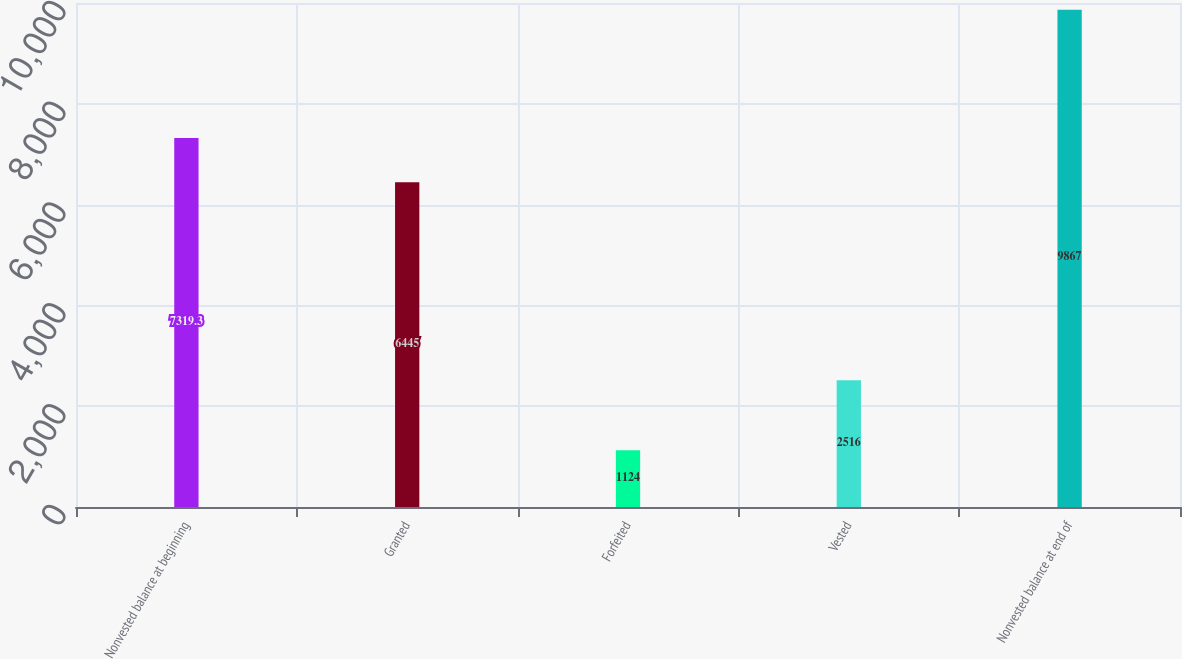Convert chart to OTSL. <chart><loc_0><loc_0><loc_500><loc_500><bar_chart><fcel>Nonvested balance at beginning<fcel>Granted<fcel>Forfeited<fcel>Vested<fcel>Nonvested balance at end of<nl><fcel>7319.3<fcel>6445<fcel>1124<fcel>2516<fcel>9867<nl></chart> 